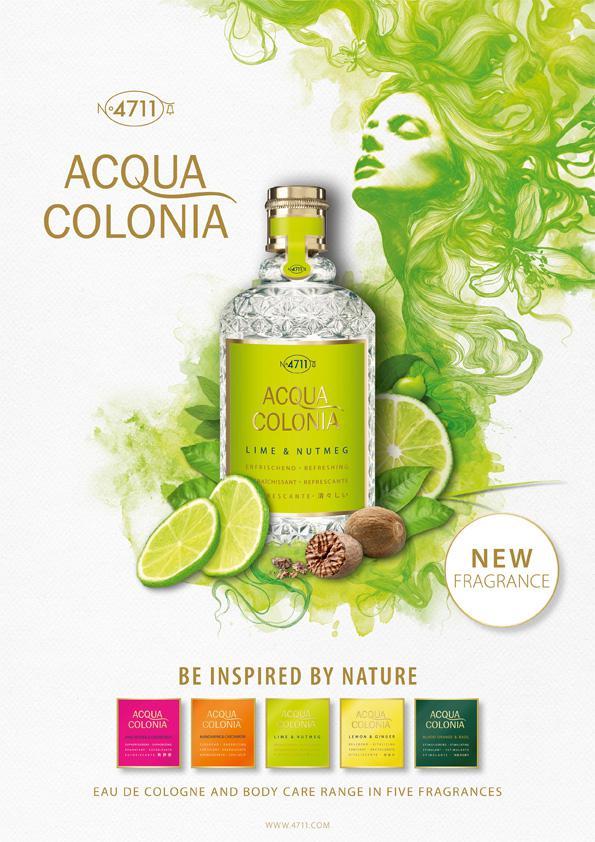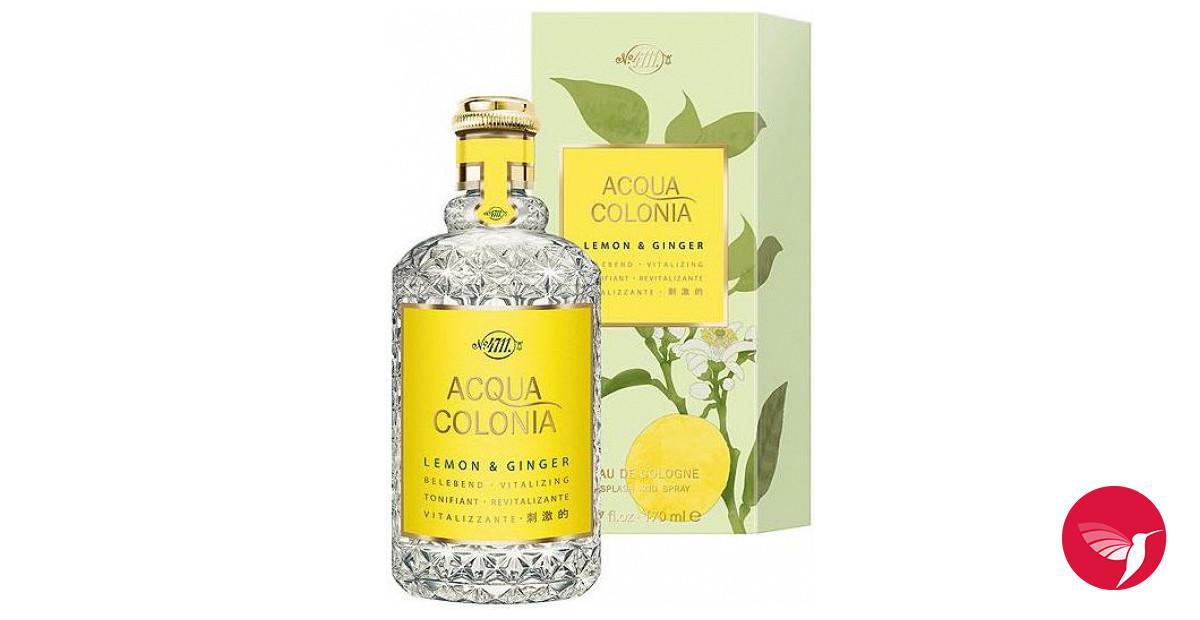The first image is the image on the left, the second image is the image on the right. Examine the images to the left and right. Is the description "Some of the bottles are surrounded by flowers." accurate? Answer yes or no. No. The first image is the image on the left, the second image is the image on the right. Evaluate the accuracy of this statement regarding the images: "One of the images shows three bottles of perfume surrounded by flowers.". Is it true? Answer yes or no. No. 